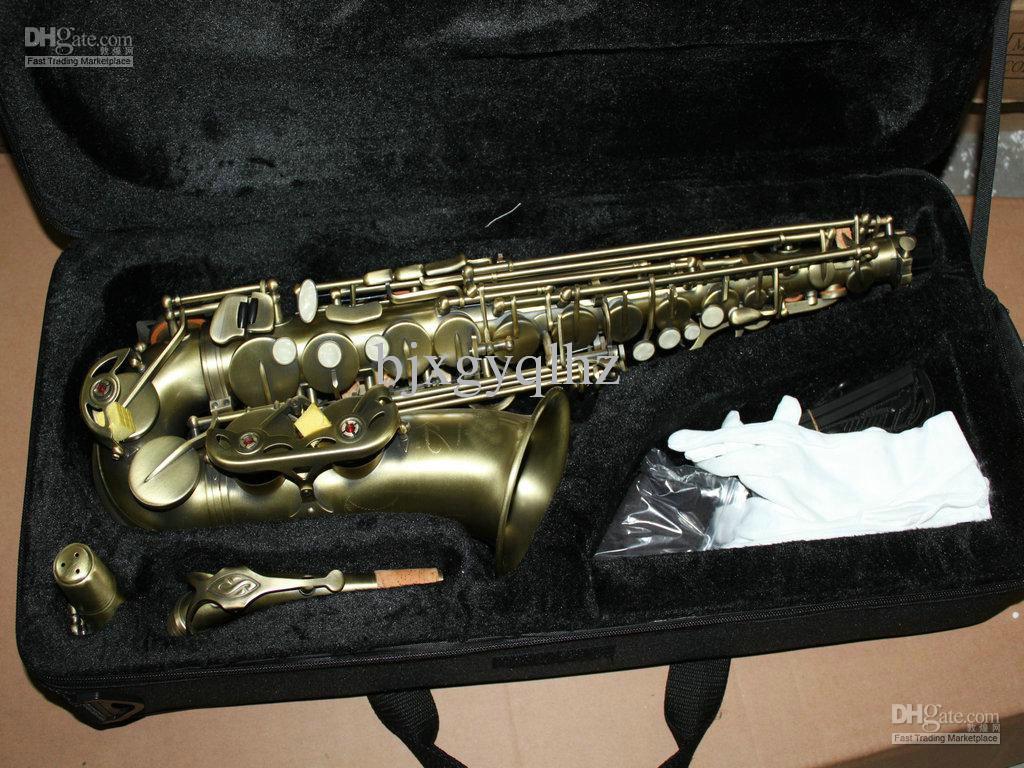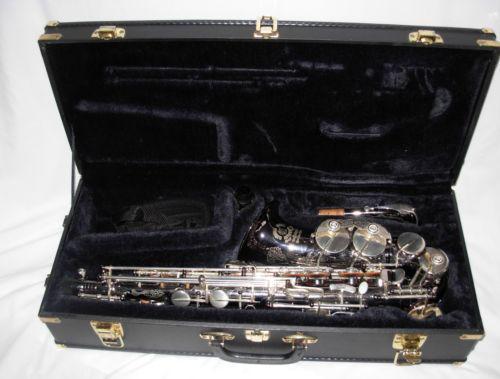The first image is the image on the left, the second image is the image on the right. For the images shown, is this caption "At least one saxophone case has a burgundy velvet interior." true? Answer yes or no. No. The first image is the image on the left, the second image is the image on the right. Analyze the images presented: Is the assertion "An image shows a rounded, not rectangular, case, which is lined in black fabric and holds one saxophone." valid? Answer yes or no. No. 